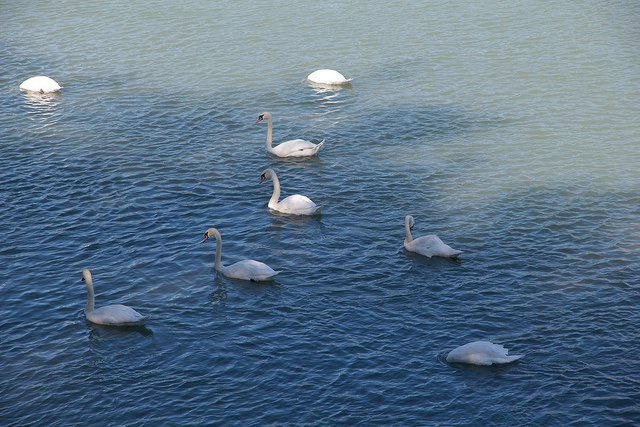Describe the objects in this image and their specific colors. I can see bird in darkgray and gray tones, bird in darkgray and gray tones, bird in darkgray and gray tones, bird in darkgray, lightgray, and gray tones, and bird in darkgray and gray tones in this image. 